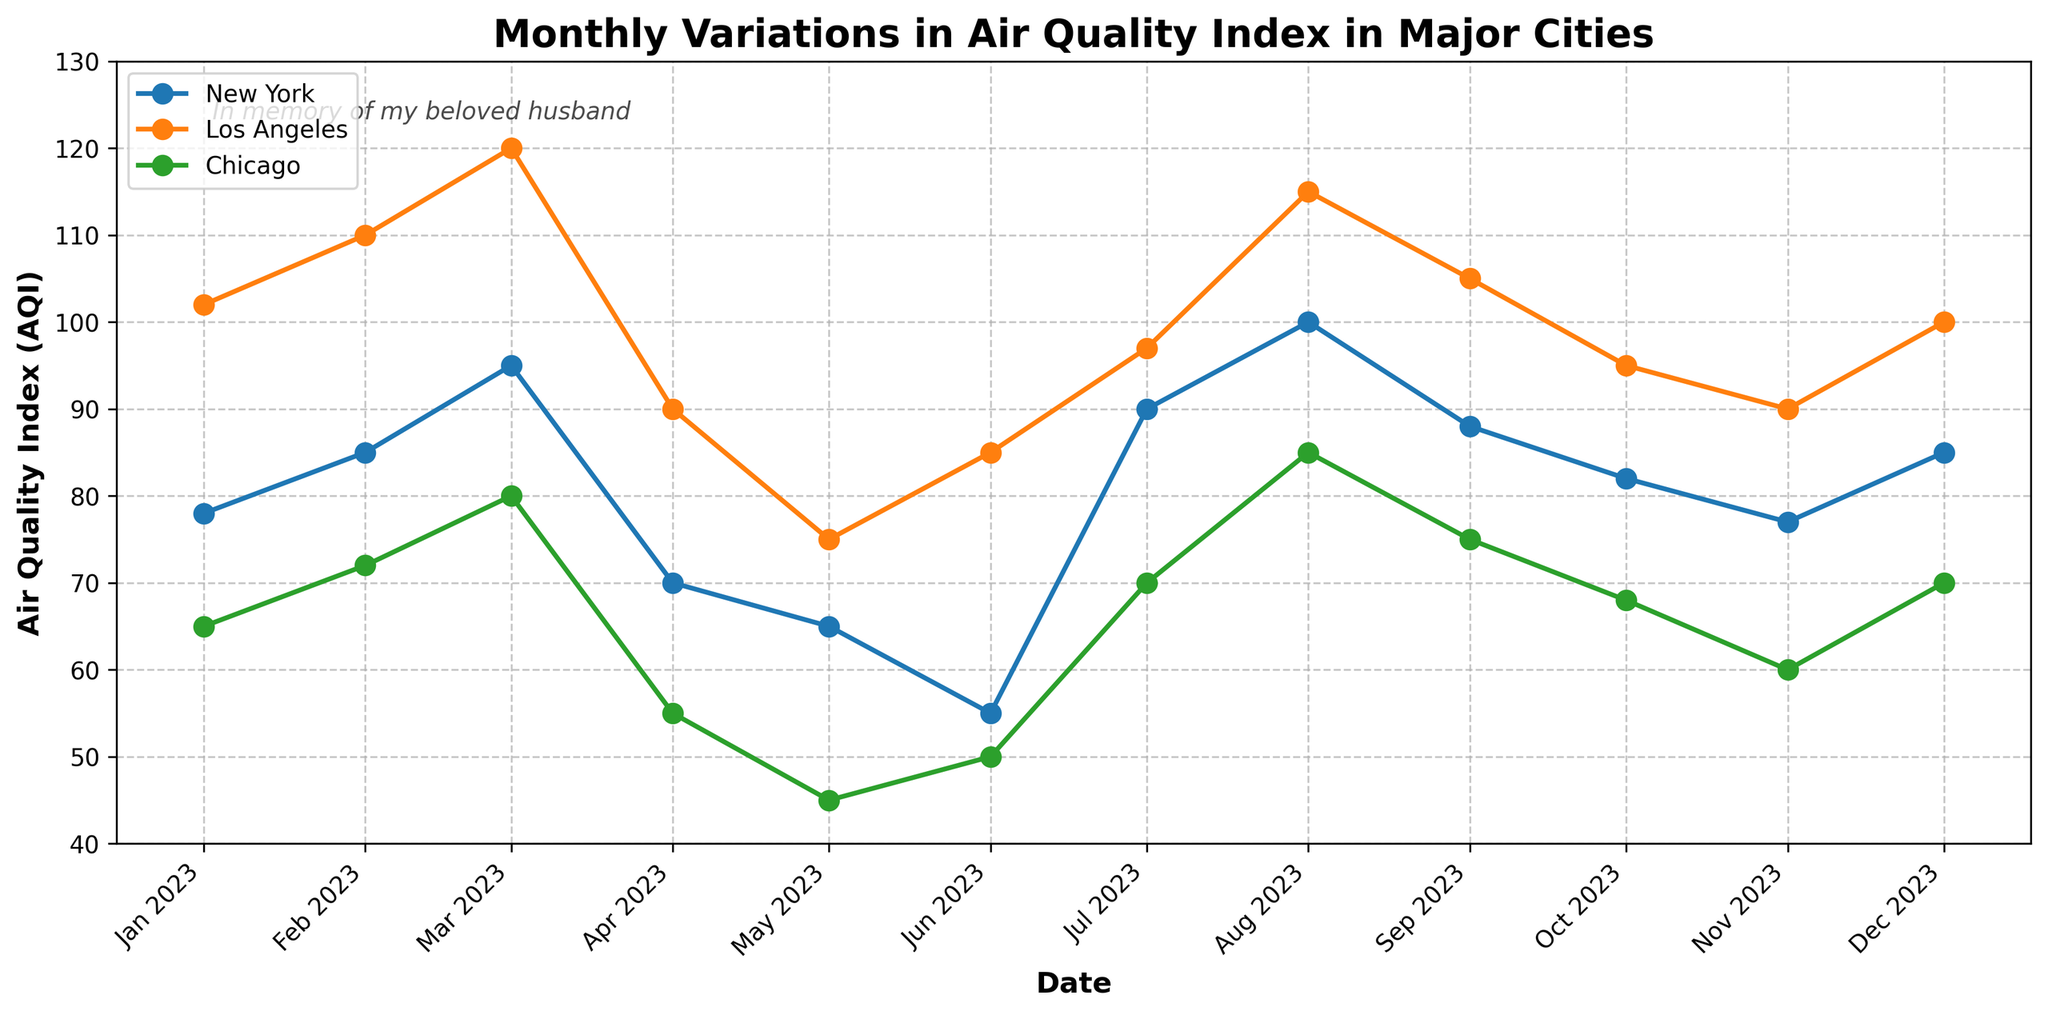What is the title of the figure? The title of the figure can be found at the top and is a direct description of the content of the plot.
Answer: Monthly Variations in Air Quality Index in Major Cities Which city had the highest AQI in January 2023? To determine the highest AQI for January 2023, find the date "2023-01-01" and compare the AQI values for New York, Los Angeles, and Chicago.
Answer: Los Angeles What was the AQI in Chicago in May 2023? Locate the data point for Chicago on the timeline for May 2023. Refer to the AQI value noted for Chicago at that point on the graph.
Answer: 45 How did the AQI of Los Angeles change from January 2023 to December 2023? Locate both the January 2023 and December 2023 points for Los Angeles. Subtract the January AQI value from the December AQI value to determine the change.
Answer: Decreased by 2 Which month had the lowest AQI for New York? Identify and compare all AQI values for New York. The lowest value among them corresponds to the month of interest.
Answer: June 2023 From the months listed, in which month did all the cities experience their lowest AQI values simultaneously? Review the graph to identify the month with the lowest AQI values for all cities. Compare each month across all cities to determine if they all reach their lowest points at the same time.
Answer: May 2023 Was there any month when the AQI of Chicago was categorized as 'Unhealthy for Sensitive Groups'? Review the health impact labels for Chicago across all months. Look for any month where the label reads 'Unhealthy for Sensitive Groups'.
Answer: No Compare the AQI trend for New York and Los Angeles. Which city shows a more consistent pattern over the year? Observe the lines for both New York and Los Angeles. Assess the variability and fluctuations in AQI values over the months to determine which city displays a more consistent pattern.
Answer: New York What is the average AQI for New York over the year? Add all the monthly AQI values for New York and divide the sum by the total number of months (12) to obtain the average AQI for New York over the year.
Answer: 79.08 